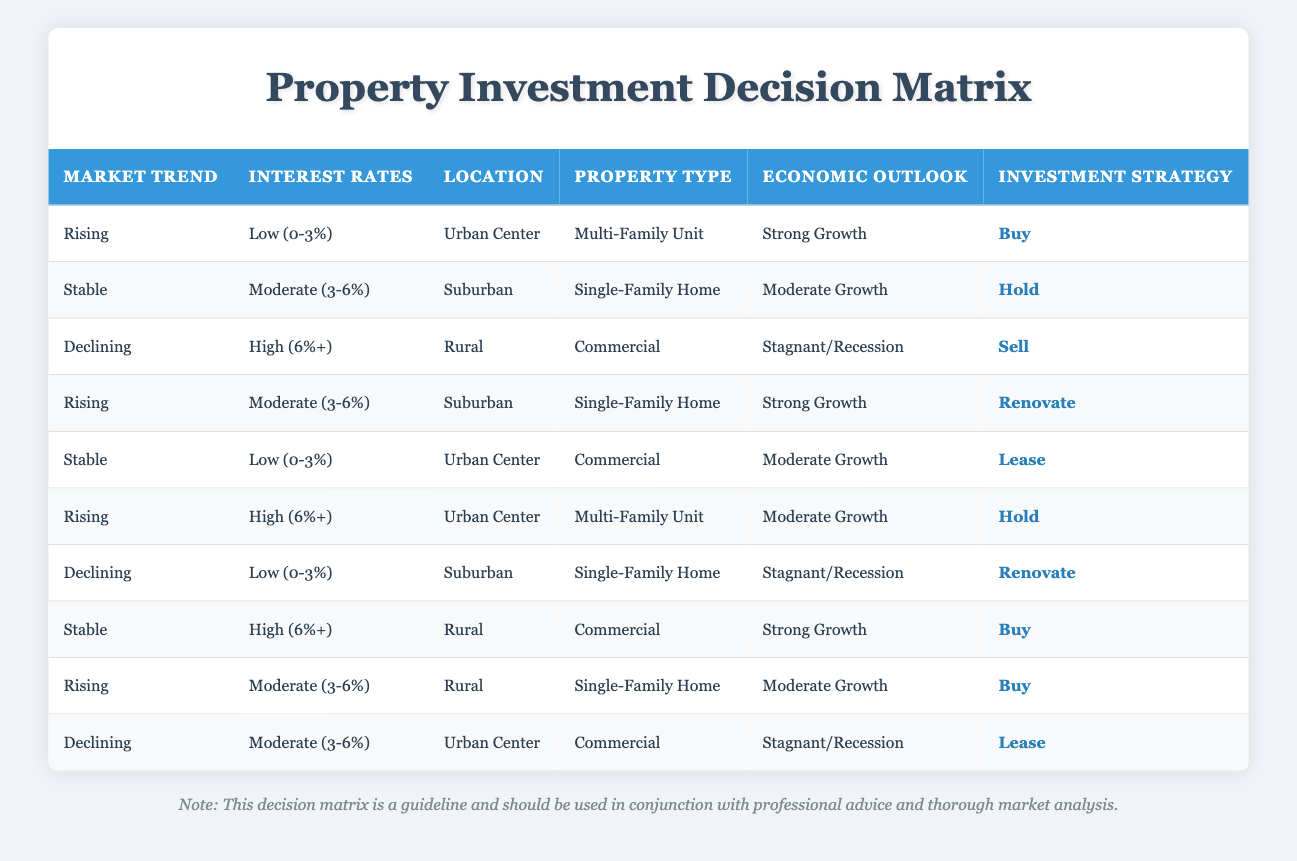What is the investment strategy when the market trend is rising, interest rates are low, and the location is an urban center? The table specifies that under these conditions, the investment strategy is "Buy." This is found in the row where the market trend is "Rising," interest rates are "Low (0-3%)," the location is "Urban Center," the property type is "Multi-Family Unit," and the economic outlook is "Strong Growth."
Answer: Buy How many investment strategies are recommended for a stable market trend? By examining the table, three rows have a market trend labeled as "Stable." Each of these provides a different investment strategy, which includes "Hold," "Lease," and "Buy." Therefore, the total count of investment strategies recommended is three.
Answer: Three Is it advisable to sell commercial properties in a declining market with high interest rates? Yes, according to the table, the row with "Declining" market trend, "High (6%+)" interest rates, "Rural" location, "Commercial" property type, and "Stagnant/Recession" economic outlook leads to a recommendation to "Sell."
Answer: Yes What investment strategy is suggested for a rural location with rising market trends and moderate interest rates? The table shows that for rural locations under "Rising" market trends and "Moderate (3-6%)" interest rates, the investment strategy is "Buy." This is found in the corresponding row where the property type is "Single-Family Home" and the economic outlook is "Moderate Growth."
Answer: Buy If the economic outlook is stagnant and the property type is commercial in a declining market, what strategy should be taken? The table indicates that in a declining situation with economic outlook categorized as "Stagnant/Recession" and the property type as "Commercial," it is suggested to "Lease." This can be traced in the row where the market trend is "Declining," interest rates are "Moderate (3-6%)," and location is "Urban Center."
Answer: Lease What is the difference in investment strategies between strong growth economic outlook and stagnant/recession outlook for rising market trends? For the rising market trends, when the economic outlook is "Strong Growth" and the property type is "Multi-Family Unit," the strategy is to "Buy." In contrast, if the economic outlook is "Stagnant/Recession," the investment approach is less favorable and cannot be directly seen as "Buy." In both cases, the former results in a definitive "Buy" recommendation compared to a lacking strategy in the latter scenario.
Answer: Buy vs. No specific strategy Are there any investment strategies recommended for commercial properties? Yes, there are two instances in the table that recommend strategies for commercial properties: one is to "Lease" under a stable market with low interest rates, and the second is to "Sell" in a declining market with high interest rates. This is confirmed by reviewing the related rows in the table.
Answer: Yes What is the investment strategy for properties that are suburban, single-family homes with moderate economic growth under stable market conditions? For suburban single-family homes under stable market conditions and moderate economic growth, the investment strategy is explicitly stated as "Hold." This is sourced from the specific row in the table describing these conditions.
Answer: Hold How many different property types are associated with the "Buy" investment strategy? The table indicates that there are three different entries where the investment strategy is "Buy." These are associated with "Multi-Family Unit" in urban centers with rising trends and strong growth and "Single-Family Home" in rural areas with rising trends and moderate growth. Thus, the count of distinct property types linked to "Buy" is two: Multi-Family Unit and Single-Family Home.
Answer: Two 